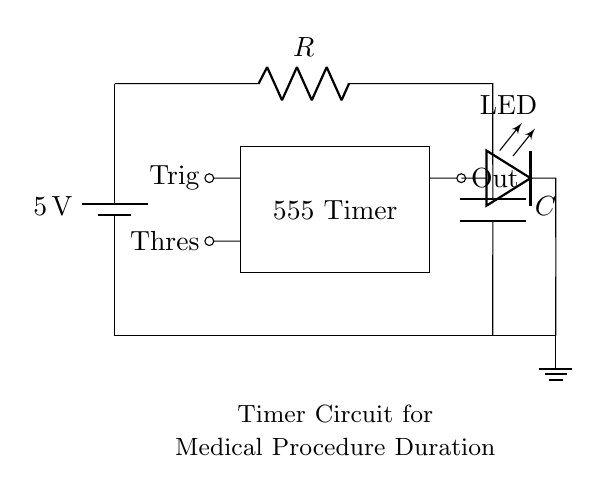What is the voltage of this circuit? The voltage is 5 volts, indicated by the battery symbol at the left side of the circuit diagram. It is the power source for the entire circuit.
Answer: 5 volts What type of component is the main controller in this circuit? The main controller is the 555 Timer, which is represented by the rectangle labeled "555 Timer" in the diagram. This component is crucial for timing applications.
Answer: 555 Timer What device provides the visual indication in this circuit? The visual indication is provided by the LED, which is connected to the output of the 555 Timer as marked in the diagram. It lights up when the timer activates.
Answer: LED Which components determine the timing duration of the circuit? The timing duration is determined by the resistor and the capacitor, labeled R and C in the circuit. Their values affect how long the timer runs before turning off.
Answer: Resistor and Capacitor What is the purpose of the ground connection in this circuit? The ground connection provides a return path for the current and serves as a reference point for all voltages in the circuit, ensuring proper functioning of the components.
Answer: Return path How can you increase the timer duration in this circuit? To increase the timer duration, you can either increase the resistance value (R) or the capacitance value (C), which are connected in series as part of the timing circuit of the 555 timer.
Answer: Increase R or C 